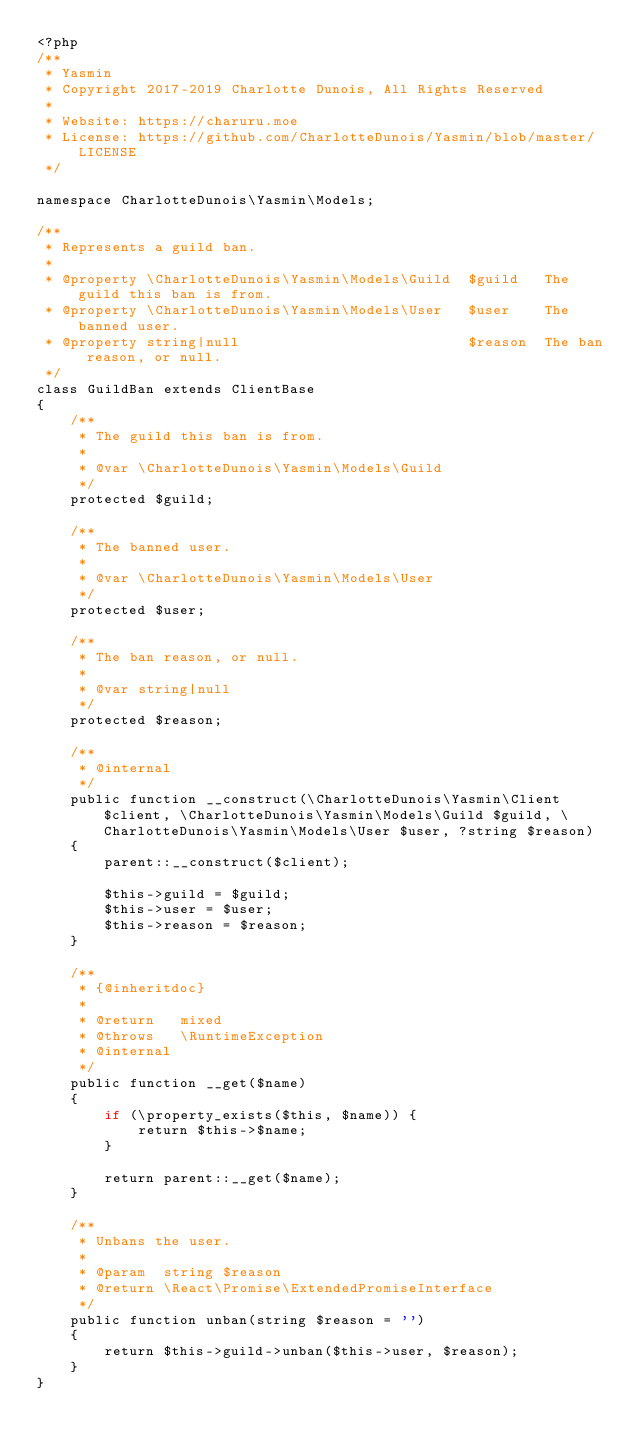Convert code to text. <code><loc_0><loc_0><loc_500><loc_500><_PHP_><?php
/**
 * Yasmin
 * Copyright 2017-2019 Charlotte Dunois, All Rights Reserved
 *
 * Website: https://charuru.moe
 * License: https://github.com/CharlotteDunois/Yasmin/blob/master/LICENSE
 */

namespace CharlotteDunois\Yasmin\Models;

/**
 * Represents a guild ban.
 *
 * @property \CharlotteDunois\Yasmin\Models\Guild  $guild   The guild this ban is from.
 * @property \CharlotteDunois\Yasmin\Models\User   $user    The banned user.
 * @property string|null                           $reason  The ban reason, or null.
 */
class GuildBan extends ClientBase
{
    /**
     * The guild this ban is from.
     *
     * @var \CharlotteDunois\Yasmin\Models\Guild
     */
    protected $guild;

    /**
     * The banned user.
     *
     * @var \CharlotteDunois\Yasmin\Models\User
     */
    protected $user;

    /**
     * The ban reason, or null.
     *
     * @var string|null
     */
    protected $reason;

    /**
     * @internal
     */
    public function __construct(\CharlotteDunois\Yasmin\Client $client, \CharlotteDunois\Yasmin\Models\Guild $guild, \CharlotteDunois\Yasmin\Models\User $user, ?string $reason)
    {
        parent::__construct($client);

        $this->guild = $guild;
        $this->user = $user;
        $this->reason = $reason;
    }

    /**
     * {@inheritdoc}
     *
     * @return   mixed
     * @throws   \RuntimeException
     * @internal
     */
    public function __get($name)
    {
        if (\property_exists($this, $name)) {
            return $this->$name;
        }

        return parent::__get($name);
    }

    /**
     * Unbans the user.
     *
     * @param  string $reason
     * @return \React\Promise\ExtendedPromiseInterface
     */
    public function unban(string $reason = '')
    {
        return $this->guild->unban($this->user, $reason);
    }
}
</code> 